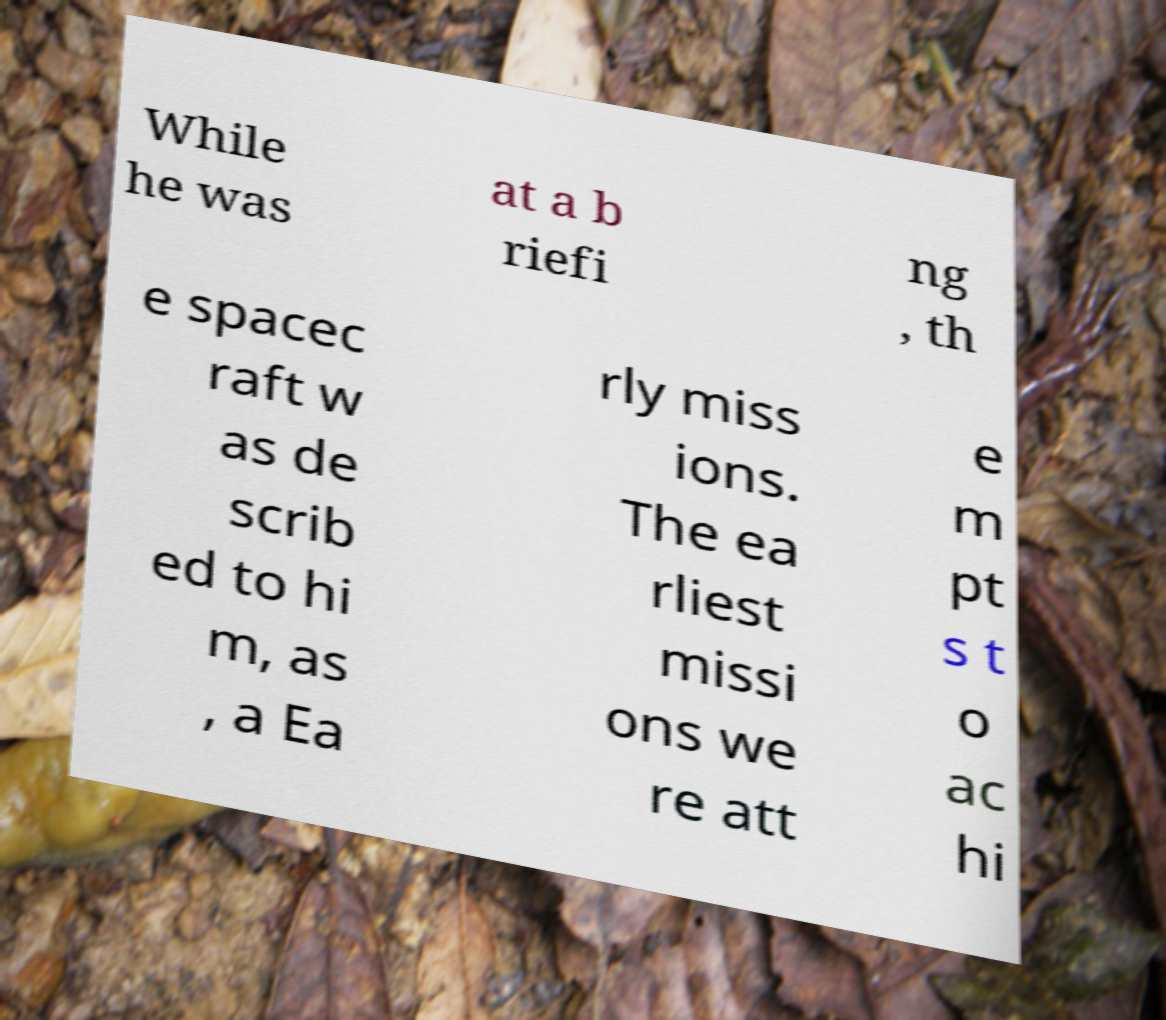Please identify and transcribe the text found in this image. While he was at a b riefi ng , th e spacec raft w as de scrib ed to hi m, as , a Ea rly miss ions. The ea rliest missi ons we re att e m pt s t o ac hi 